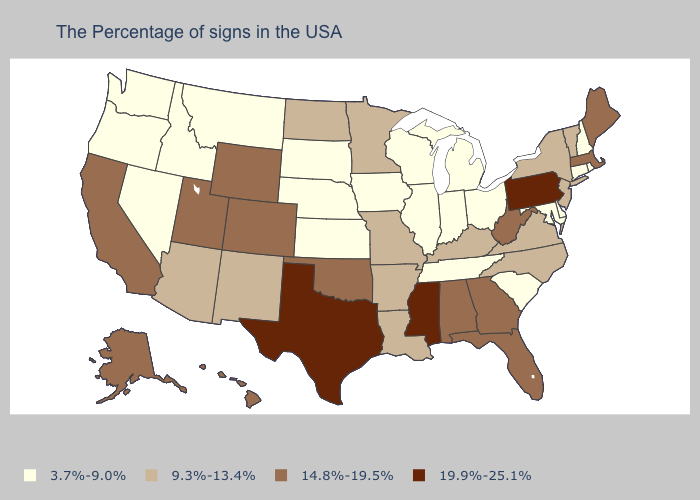Does Massachusetts have the highest value in the Northeast?
Answer briefly. No. Does the first symbol in the legend represent the smallest category?
Short answer required. Yes. Which states have the highest value in the USA?
Concise answer only. Pennsylvania, Mississippi, Texas. Which states have the highest value in the USA?
Concise answer only. Pennsylvania, Mississippi, Texas. What is the value of South Dakota?
Concise answer only. 3.7%-9.0%. Name the states that have a value in the range 3.7%-9.0%?
Concise answer only. Rhode Island, New Hampshire, Connecticut, Delaware, Maryland, South Carolina, Ohio, Michigan, Indiana, Tennessee, Wisconsin, Illinois, Iowa, Kansas, Nebraska, South Dakota, Montana, Idaho, Nevada, Washington, Oregon. Does New Jersey have the lowest value in the USA?
Be succinct. No. Name the states that have a value in the range 9.3%-13.4%?
Keep it brief. Vermont, New York, New Jersey, Virginia, North Carolina, Kentucky, Louisiana, Missouri, Arkansas, Minnesota, North Dakota, New Mexico, Arizona. Is the legend a continuous bar?
Concise answer only. No. What is the value of North Dakota?
Keep it brief. 9.3%-13.4%. Name the states that have a value in the range 14.8%-19.5%?
Keep it brief. Maine, Massachusetts, West Virginia, Florida, Georgia, Alabama, Oklahoma, Wyoming, Colorado, Utah, California, Alaska, Hawaii. Which states have the lowest value in the USA?
Write a very short answer. Rhode Island, New Hampshire, Connecticut, Delaware, Maryland, South Carolina, Ohio, Michigan, Indiana, Tennessee, Wisconsin, Illinois, Iowa, Kansas, Nebraska, South Dakota, Montana, Idaho, Nevada, Washington, Oregon. Name the states that have a value in the range 14.8%-19.5%?
Quick response, please. Maine, Massachusetts, West Virginia, Florida, Georgia, Alabama, Oklahoma, Wyoming, Colorado, Utah, California, Alaska, Hawaii. Name the states that have a value in the range 3.7%-9.0%?
Give a very brief answer. Rhode Island, New Hampshire, Connecticut, Delaware, Maryland, South Carolina, Ohio, Michigan, Indiana, Tennessee, Wisconsin, Illinois, Iowa, Kansas, Nebraska, South Dakota, Montana, Idaho, Nevada, Washington, Oregon. What is the value of Utah?
Give a very brief answer. 14.8%-19.5%. 